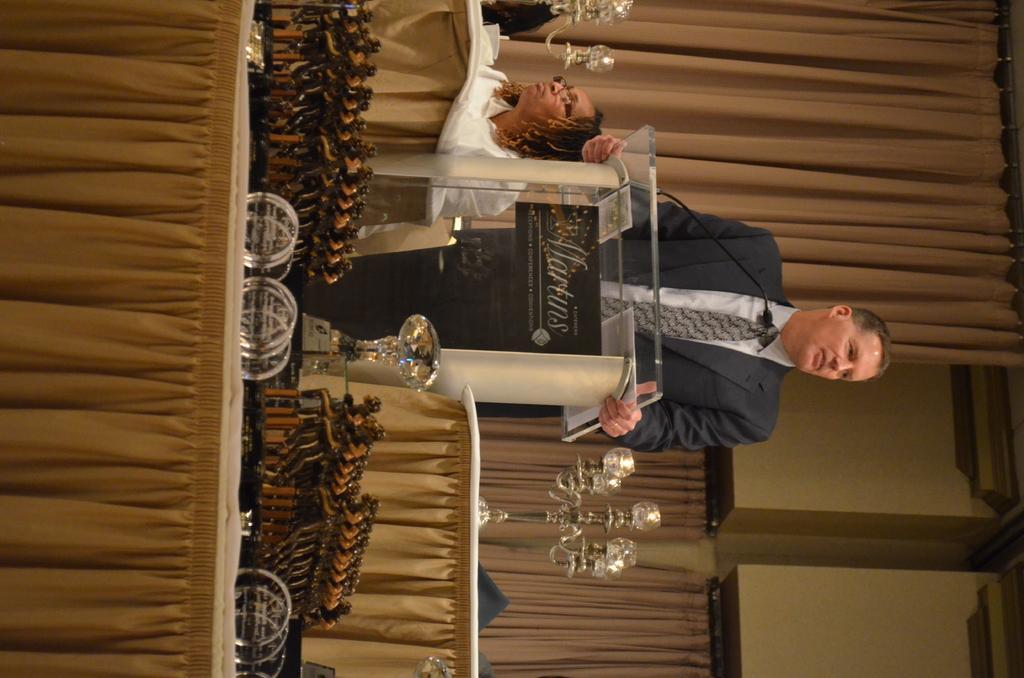Describe this image in one or two sentences. This is a rotated image. A man wearing black suit and tie is standing in front of a podium. There is a mic in front of the person. On both side of the podium there are tables and chairs. On a chair a lady is sitting. On the table there are lights. In front of the podium there is a trophy and few statues are kept. In the left on a table there are glasses. 